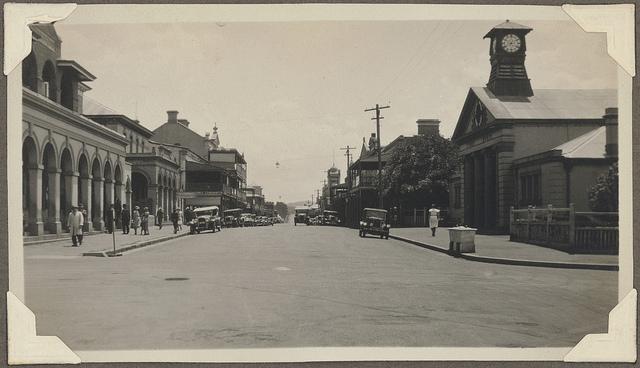Is there any lines on the street?
Write a very short answer. No. Is there a clock in the photo?
Short answer required. Yes. What year was the car made on the left hand side of the photograph?
Short answer required. 1920. 